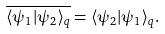<formula> <loc_0><loc_0><loc_500><loc_500>\overline { \langle \psi _ { 1 } | \psi _ { 2 } \rangle _ { q } } = \langle \psi _ { 2 } | \psi _ { 1 } \rangle _ { q } .</formula> 